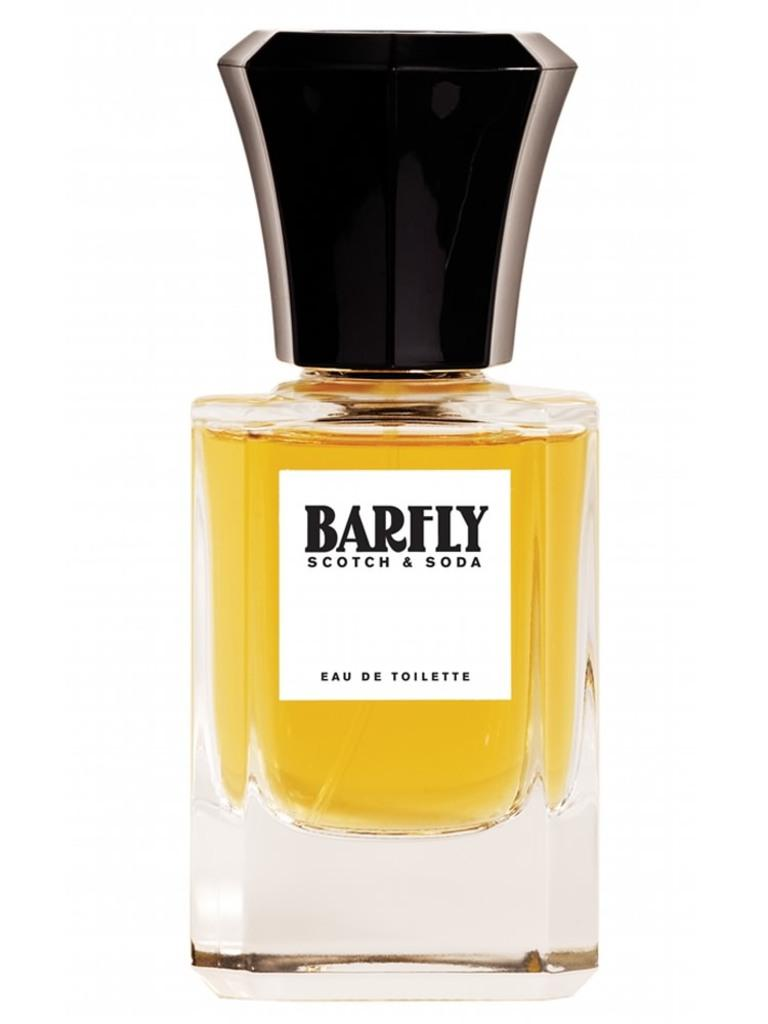<image>
Write a terse but informative summary of the picture. Bottle of Barfly Scotch & Soda with a large black cap. 